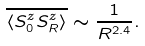<formula> <loc_0><loc_0><loc_500><loc_500>\overline { \langle S _ { 0 } ^ { z } S _ { R } ^ { z } \rangle } \sim \frac { 1 } { R ^ { 2 . 4 } } .</formula> 